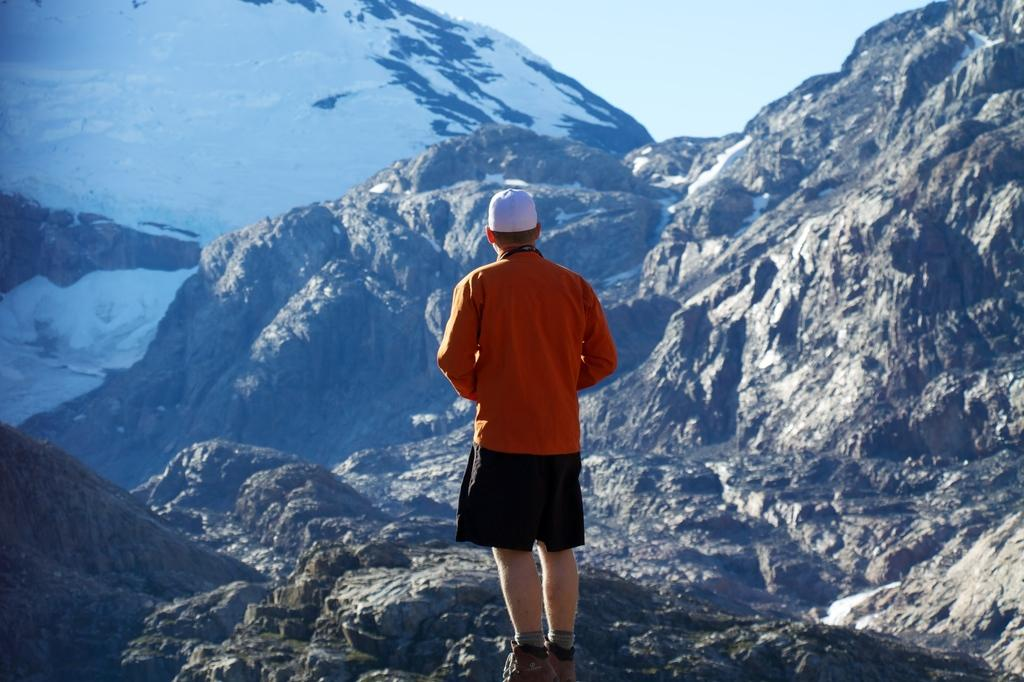What is the main subject of the image? There is a man standing in the center of the image. What is the man wearing on his head? The man is wearing a cap. What can be seen in the distance behind the man? There are hills visible in the background of the image. What is visible above the hills in the image? The sky is visible in the background of the image. What type of wood can be seen in the image? There is no wood present in the image; it features a man standing in the center with hills and the sky visible in the background. 